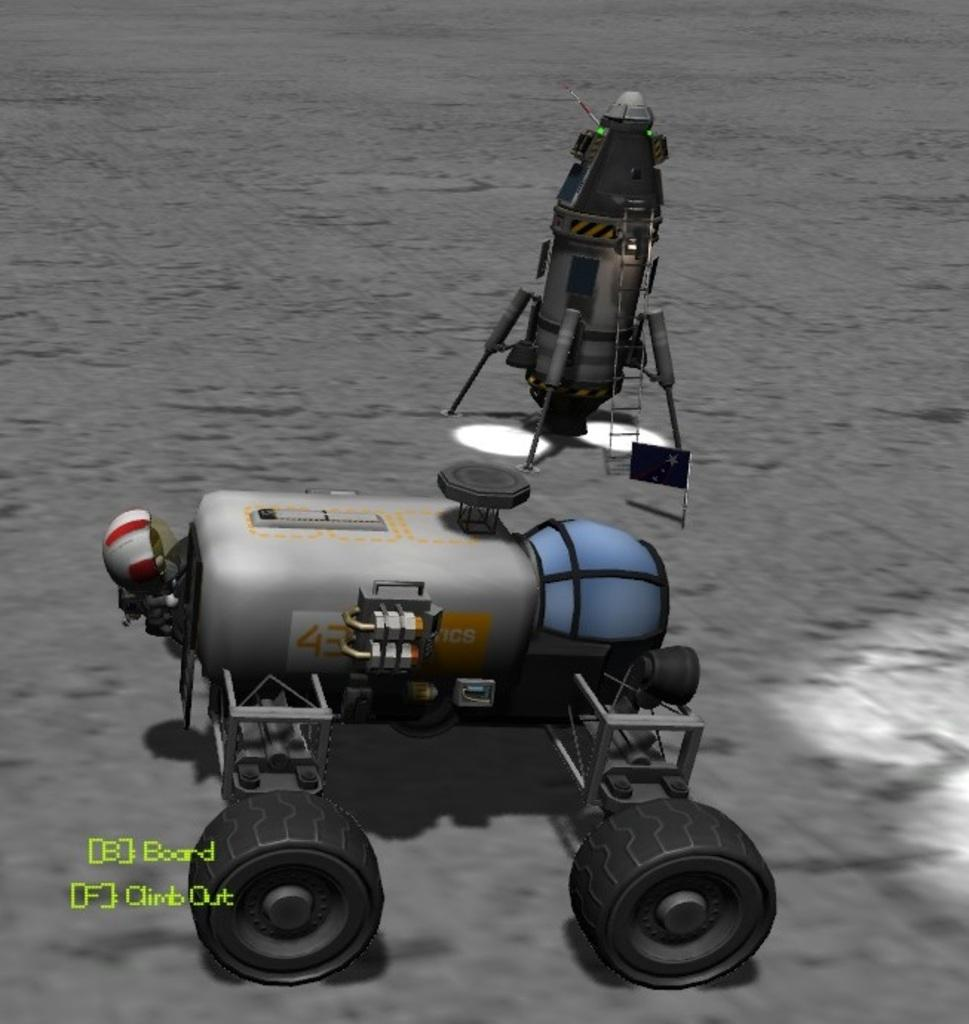Provide a one-sentence caption for the provided image. A graphic image of a robot with B for board and F to climb out. 